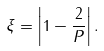<formula> <loc_0><loc_0><loc_500><loc_500>\xi = \left | 1 - \frac { 2 } { P } \right | .</formula> 